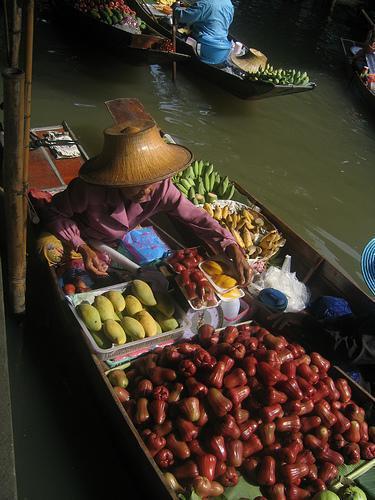How many boats are in the photo?
Give a very brief answer. 3. How many people are in the picture?
Give a very brief answer. 2. 